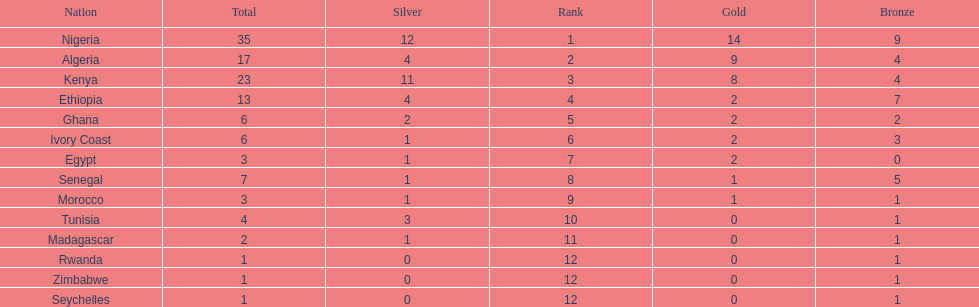What is the name of the first nation on this chart? Nigeria. 